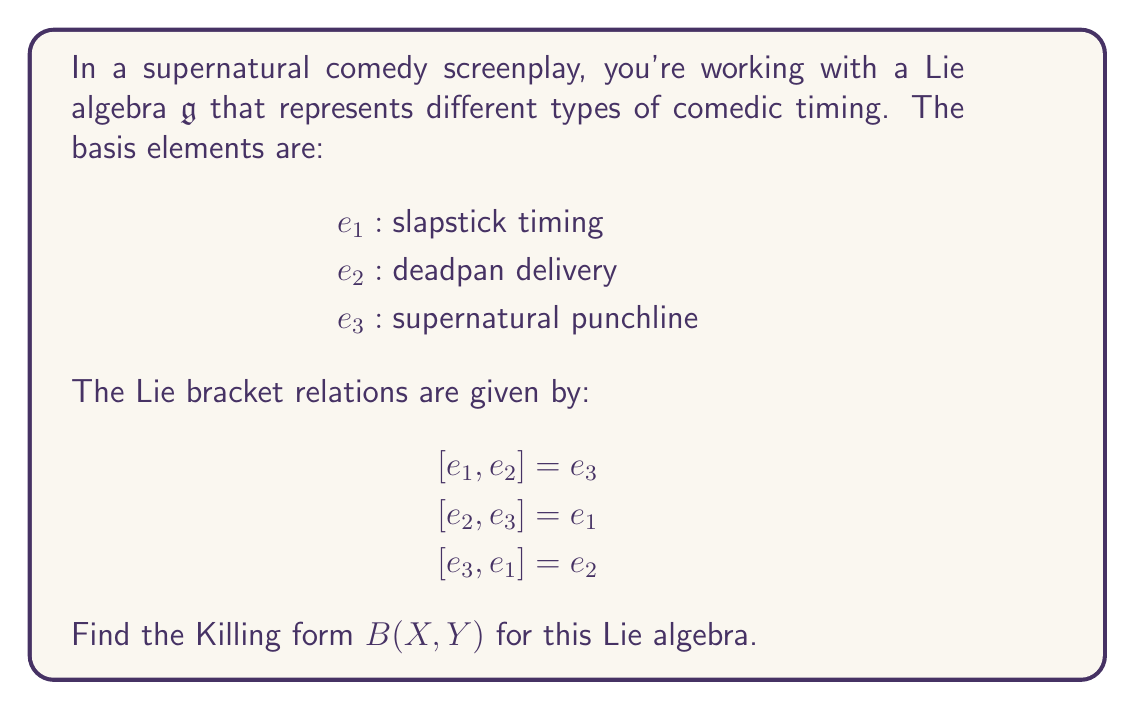Show me your answer to this math problem. To find the Killing form for this Lie algebra, we need to follow these steps:

1) The Killing form is defined as $B(X,Y) = \text{tr}(\text{ad}_X \circ \text{ad}_Y)$, where $\text{ad}_X$ is the adjoint representation of $X$.

2) First, we need to find the matrix representation of $\text{ad}_{e_i}$ for each basis element:

   For $\text{ad}_{e_1}$:
   $[e_1, e_1] = 0$
   $[e_1, e_2] = e_3$
   $[e_1, e_3] = -e_2$
   
   So, $\text{ad}_{e_1} = \begin{pmatrix} 0 & 0 & 0 \\ 0 & 0 & -1 \\ 0 & 1 & 0 \end{pmatrix}$

   Similarly:
   $\text{ad}_{e_2} = \begin{pmatrix} 0 & 0 & 1 \\ 0 & 0 & 0 \\ -1 & 0 & 0 \end{pmatrix}$

   $\text{ad}_{e_3} = \begin{pmatrix} 0 & -1 & 0 \\ 1 & 0 & 0 \\ 0 & 0 & 0 \end{pmatrix}$

3) Now, we need to compute $B(e_i, e_j)$ for all $i,j \in \{1,2,3\}$:

   $B(e_1, e_1) = \text{tr}(\text{ad}_{e_1} \circ \text{ad}_{e_1}) = \text{tr}(\begin{pmatrix} 0 & 0 & 0 \\ 0 & -1 & 0 \\ 0 & 0 & -1 \end{pmatrix}) = -2$

   $B(e_2, e_2) = B(e_3, e_3) = -2$ (by symmetry)

   $B(e_1, e_2) = \text{tr}(\text{ad}_{e_1} \circ \text{ad}_{e_2}) = \text{tr}(\begin{pmatrix} 0 & -1 & 0 \\ 0 & 0 & 0 \\ 1 & 0 & 0 \end{pmatrix}) = 0$

   $B(e_1, e_3) = B(e_2, e_3) = 0$ (by similar calculations)

4) Therefore, the Killing form matrix is:

   $B = \begin{pmatrix} -2 & 0 & 0 \\ 0 & -2 & 0 \\ 0 & 0 & -2 \end{pmatrix}$

5) We can express the Killing form as:

   $B(X,Y) = -2(x_1y_1 + x_2y_2 + x_3y_3)$

   where $X = x_1e_1 + x_2e_2 + x_3e_3$ and $Y = y_1e_1 + y_2e_2 + y_3e_3$.
Answer: The Killing form for the given Lie algebra is:

$B(X,Y) = -2(x_1y_1 + x_2y_2 + x_3y_3)$

where $X = x_1e_1 + x_2e_2 + x_3e_3$ and $Y = y_1e_1 + y_2e_2 + y_3e_3$. 